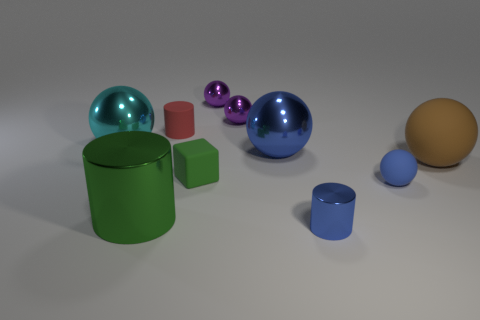Subtract all small blue shiny cylinders. How many cylinders are left? 2 Subtract all cylinders. How many objects are left? 7 Subtract 4 spheres. How many spheres are left? 2 Subtract all brown balls. How many balls are left? 5 Subtract all small cyan metal objects. Subtract all tiny rubber things. How many objects are left? 7 Add 1 big cyan metal objects. How many big cyan metal objects are left? 2 Add 6 tiny purple metallic things. How many tiny purple metallic things exist? 8 Subtract 0 gray cylinders. How many objects are left? 10 Subtract all gray cubes. Subtract all yellow balls. How many cubes are left? 1 Subtract all gray cylinders. How many gray spheres are left? 0 